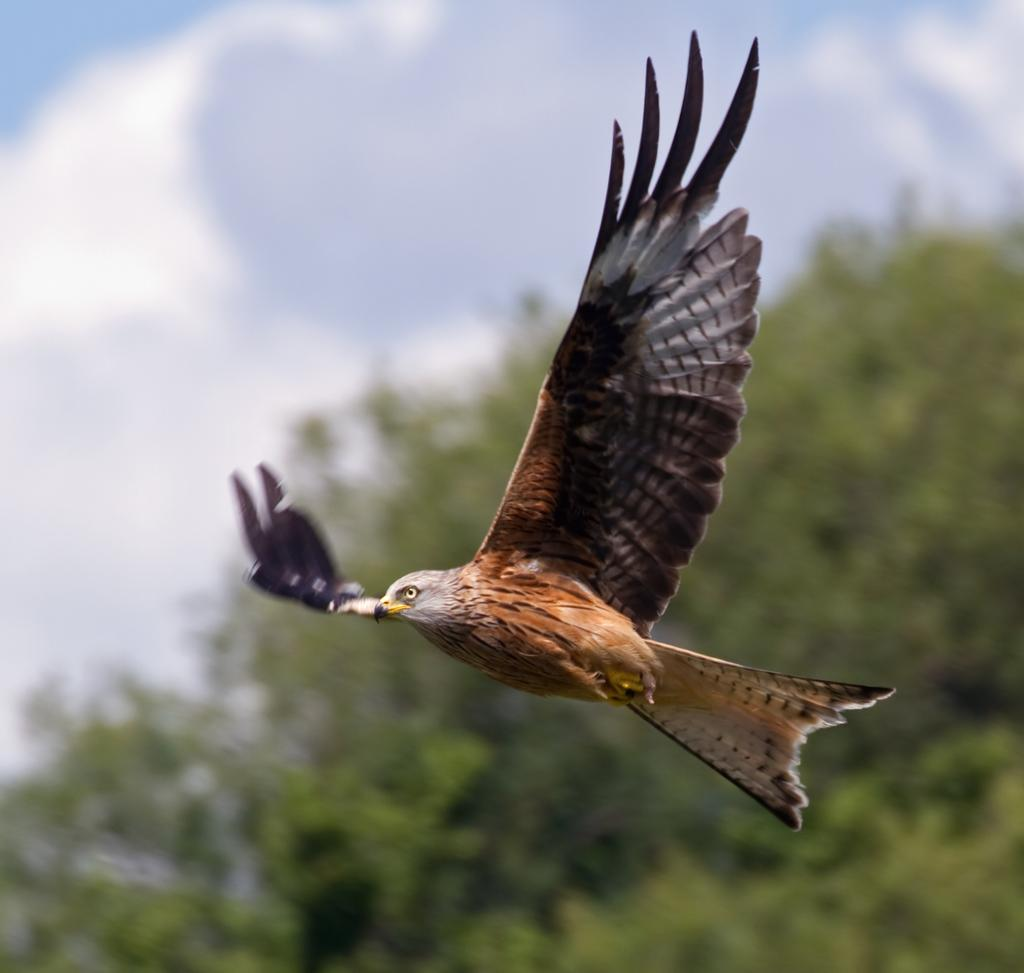What type of animal can be seen in the image? There is a bird in the image. What is the bird doing in the image? The bird is flying in the air. What can be seen in the background of the image? There are trees in the background of the image. What is visible at the top of the image? The sky is visible at the top of the image. What can be observed in the sky? Clouds are present in the sky. What type of drum is being played by the farmer in the image? There is no drum or farmer present in the image; it features a bird flying in the air with trees, sky, and clouds in the background. 